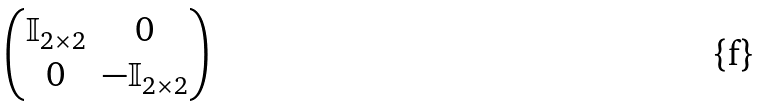Convert formula to latex. <formula><loc_0><loc_0><loc_500><loc_500>\begin{pmatrix} \mathbb { I } _ { 2 \times 2 } & 0 \\ 0 & - \mathbb { I } _ { 2 \times 2 } \end{pmatrix}</formula> 